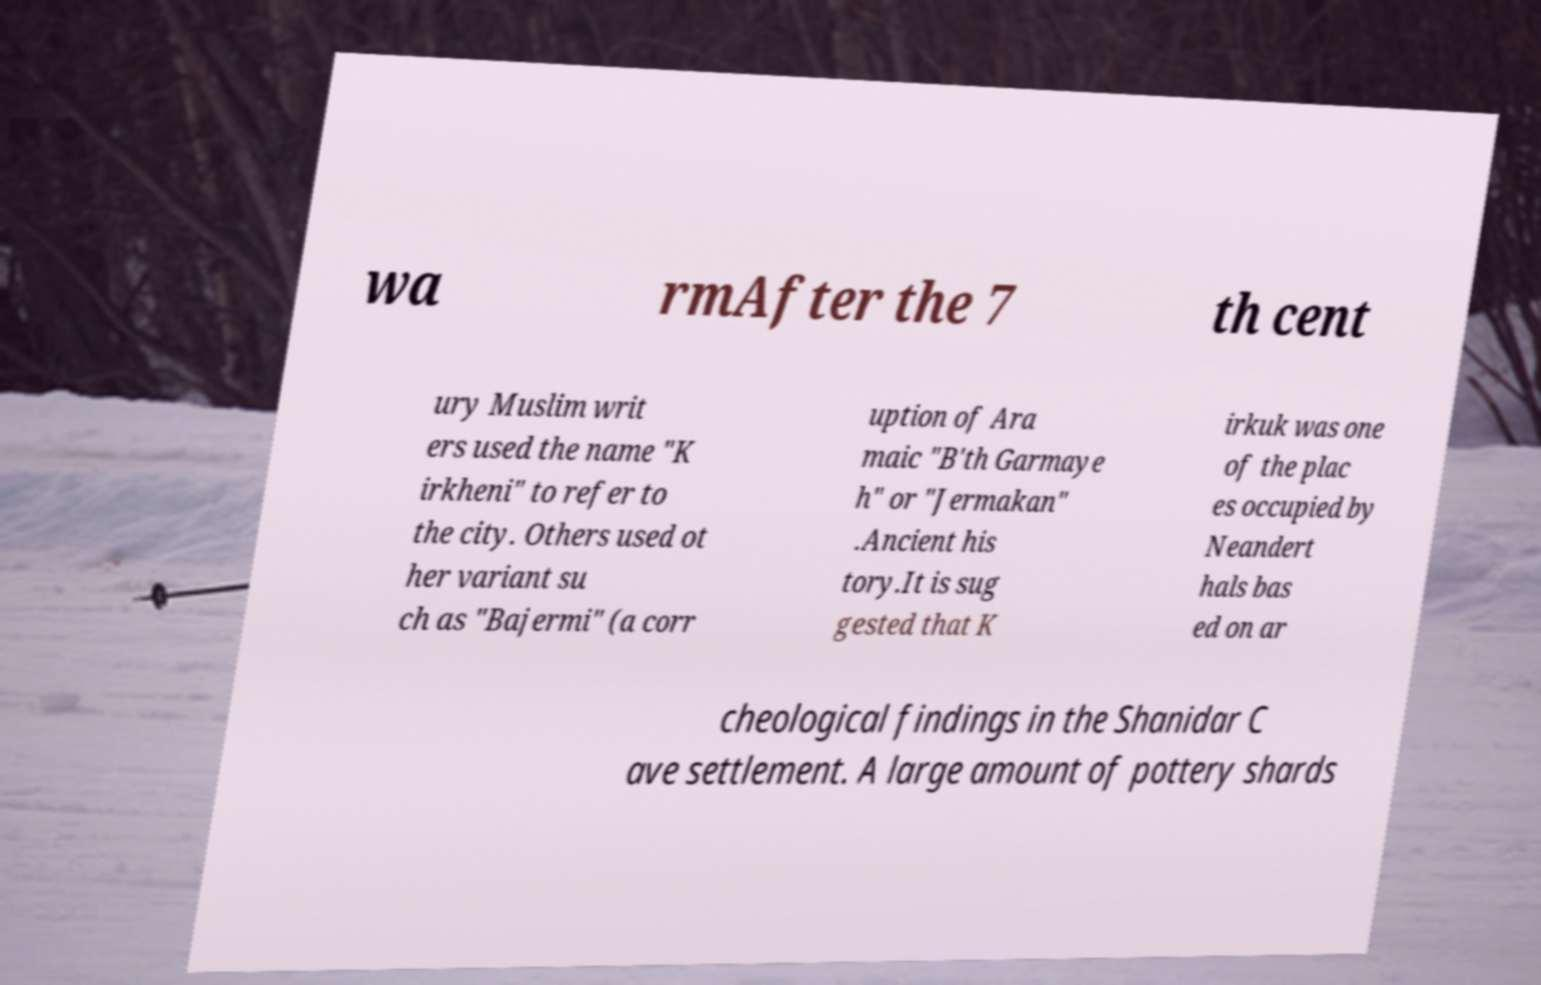Could you extract and type out the text from this image? wa rmAfter the 7 th cent ury Muslim writ ers used the name "K irkheni" to refer to the city. Others used ot her variant su ch as "Bajermi" (a corr uption of Ara maic "B'th Garmaye h" or "Jermakan" .Ancient his tory.It is sug gested that K irkuk was one of the plac es occupied by Neandert hals bas ed on ar cheological findings in the Shanidar C ave settlement. A large amount of pottery shards 